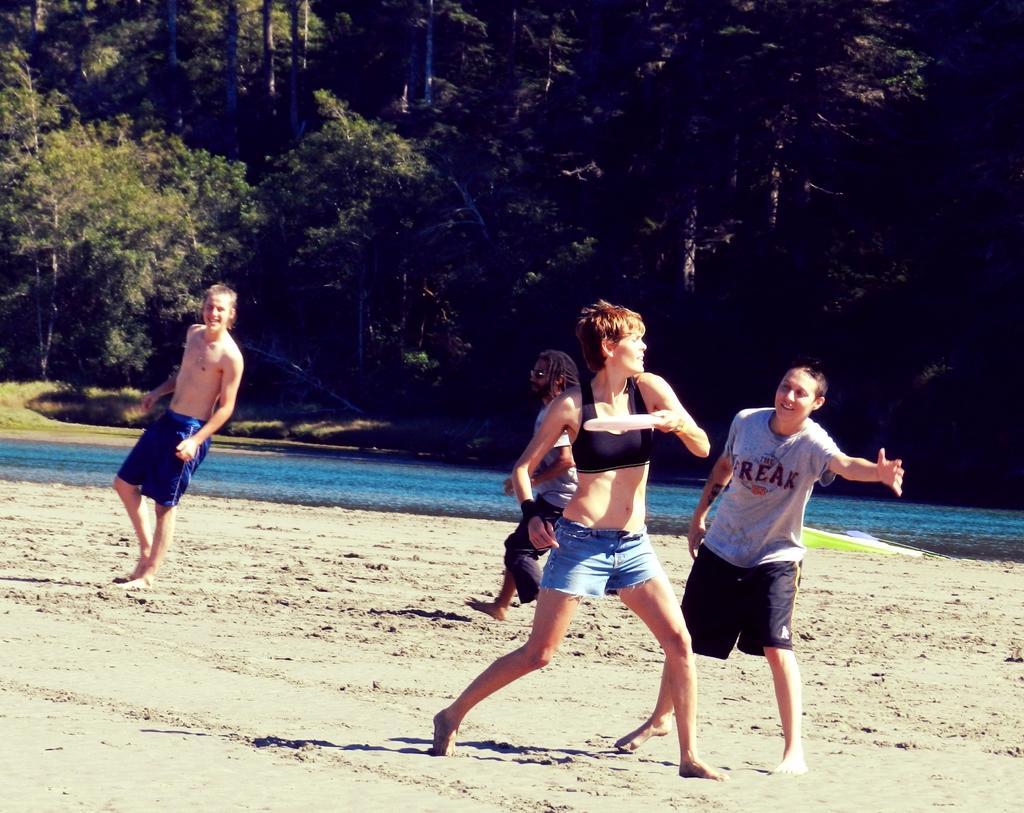Can you describe this image briefly? In this picture we can see four people, in the middle of the image we can see a woman, she is holding a disk, in the background we can see water and few trees. 